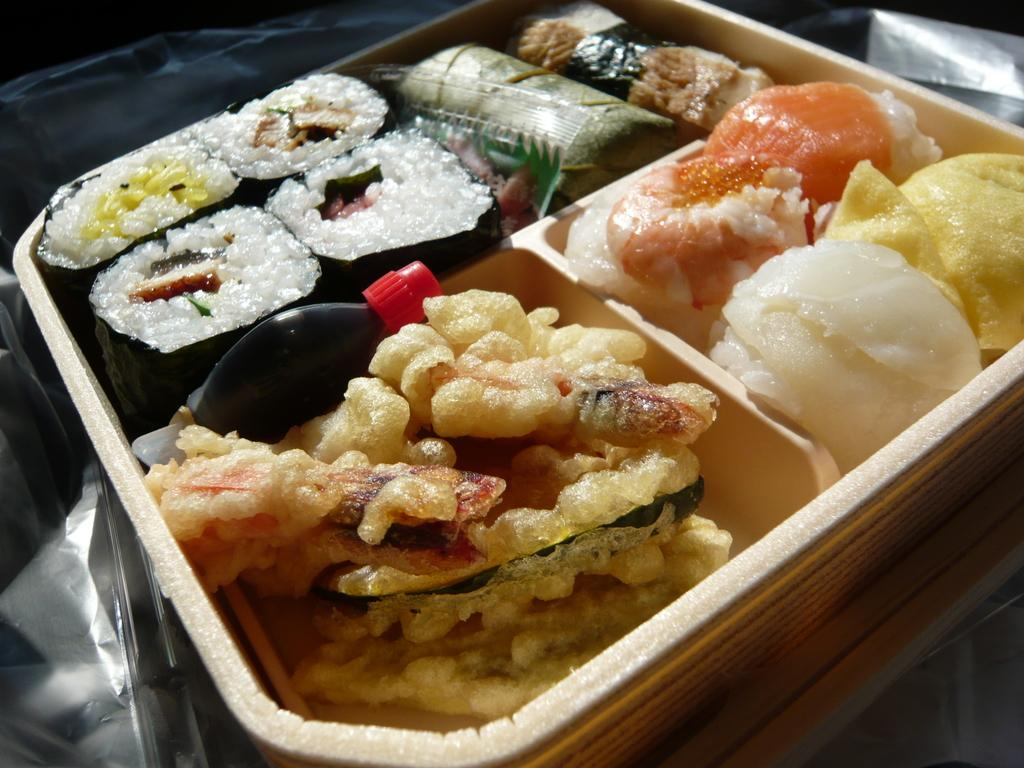What is on the plate that is visible in the image? There is a plate with food items on it. Can you describe any other objects or features in the image? There is a cover visible in the image. What type of railway is visible in the image? There is no railway present in the image. Can you describe the robin that is sitting on the plate in the image? There is no robin present in the image; it only features a plate with food items and a cover. 